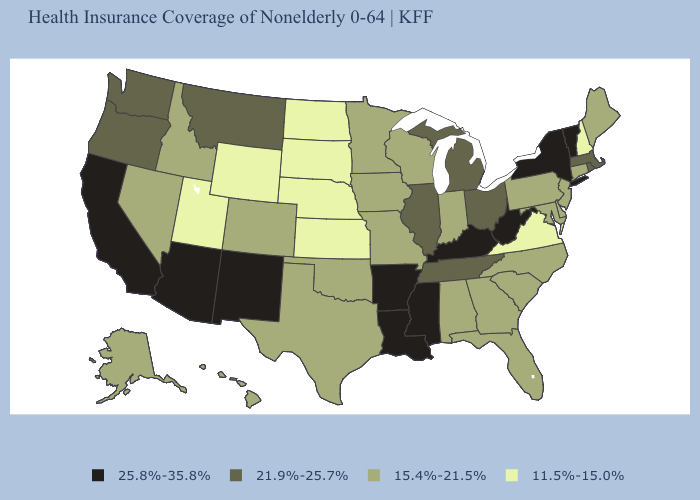Which states hav the highest value in the Northeast?
Write a very short answer. New York, Vermont. Among the states that border Iowa , does Nebraska have the lowest value?
Answer briefly. Yes. Name the states that have a value in the range 25.8%-35.8%?
Concise answer only. Arizona, Arkansas, California, Kentucky, Louisiana, Mississippi, New Mexico, New York, Vermont, West Virginia. Name the states that have a value in the range 11.5%-15.0%?
Give a very brief answer. Kansas, Nebraska, New Hampshire, North Dakota, South Dakota, Utah, Virginia, Wyoming. Name the states that have a value in the range 21.9%-25.7%?
Concise answer only. Illinois, Massachusetts, Michigan, Montana, Ohio, Oregon, Rhode Island, Tennessee, Washington. Which states have the lowest value in the USA?
Write a very short answer. Kansas, Nebraska, New Hampshire, North Dakota, South Dakota, Utah, Virginia, Wyoming. Does Maryland have a higher value than Wyoming?
Be succinct. Yes. What is the value of Massachusetts?
Be succinct. 21.9%-25.7%. Name the states that have a value in the range 21.9%-25.7%?
Write a very short answer. Illinois, Massachusetts, Michigan, Montana, Ohio, Oregon, Rhode Island, Tennessee, Washington. What is the value of Indiana?
Short answer required. 15.4%-21.5%. What is the lowest value in states that border New Hampshire?
Answer briefly. 15.4%-21.5%. What is the value of California?
Quick response, please. 25.8%-35.8%. Does Massachusetts have a lower value than Arkansas?
Answer briefly. Yes. Which states have the lowest value in the USA?
Quick response, please. Kansas, Nebraska, New Hampshire, North Dakota, South Dakota, Utah, Virginia, Wyoming. Name the states that have a value in the range 21.9%-25.7%?
Be succinct. Illinois, Massachusetts, Michigan, Montana, Ohio, Oregon, Rhode Island, Tennessee, Washington. 